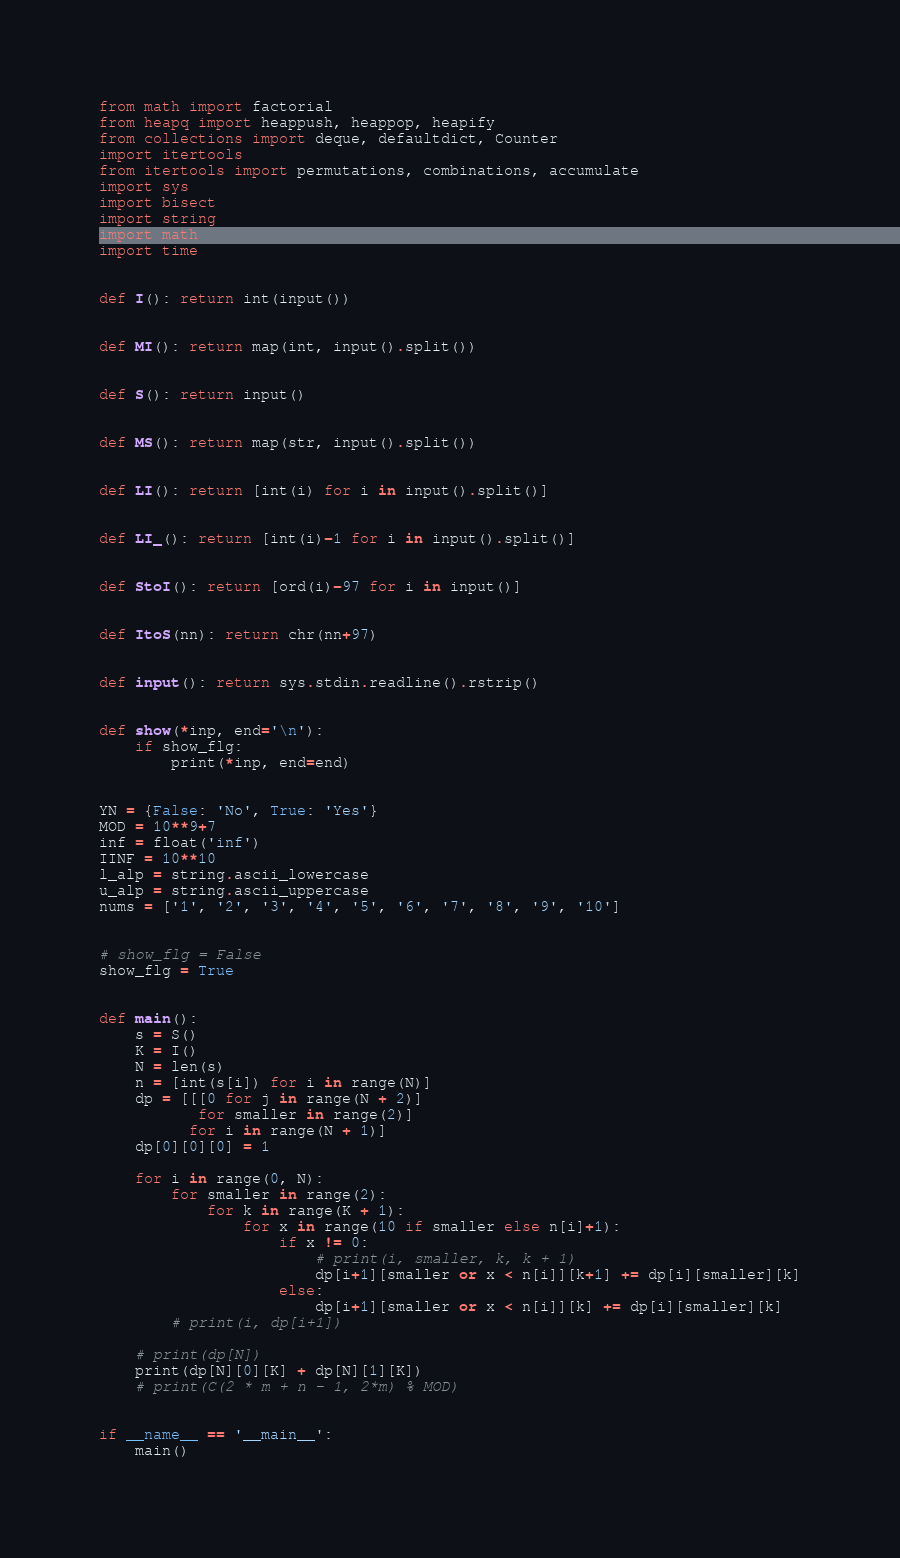Convert code to text. <code><loc_0><loc_0><loc_500><loc_500><_Python_>from math import factorial
from heapq import heappush, heappop, heapify
from collections import deque, defaultdict, Counter
import itertools
from itertools import permutations, combinations, accumulate
import sys
import bisect
import string
import math
import time


def I(): return int(input())


def MI(): return map(int, input().split())


def S(): return input()


def MS(): return map(str, input().split())


def LI(): return [int(i) for i in input().split()]


def LI_(): return [int(i)-1 for i in input().split()]


def StoI(): return [ord(i)-97 for i in input()]


def ItoS(nn): return chr(nn+97)


def input(): return sys.stdin.readline().rstrip()


def show(*inp, end='\n'):
    if show_flg:
        print(*inp, end=end)


YN = {False: 'No', True: 'Yes'}
MOD = 10**9+7
inf = float('inf')
IINF = 10**10
l_alp = string.ascii_lowercase
u_alp = string.ascii_uppercase
nums = ['1', '2', '3', '4', '5', '6', '7', '8', '9', '10']


# show_flg = False
show_flg = True


def main():
    s = S()
    K = I()
    N = len(s)
    n = [int(s[i]) for i in range(N)]
    dp = [[[0 for j in range(N + 2)]
           for smaller in range(2)]
          for i in range(N + 1)]
    dp[0][0][0] = 1

    for i in range(0, N):
        for smaller in range(2):
            for k in range(K + 1):
                for x in range(10 if smaller else n[i]+1):
                    if x != 0:
                        # print(i, smaller, k, k + 1)
                        dp[i+1][smaller or x < n[i]][k+1] += dp[i][smaller][k]
                    else:
                        dp[i+1][smaller or x < n[i]][k] += dp[i][smaller][k]
        # print(i, dp[i+1])

    # print(dp[N])
    print(dp[N][0][K] + dp[N][1][K])
    # print(C(2 * m + n - 1, 2*m) % MOD)


if __name__ == '__main__':
    main()
</code> 